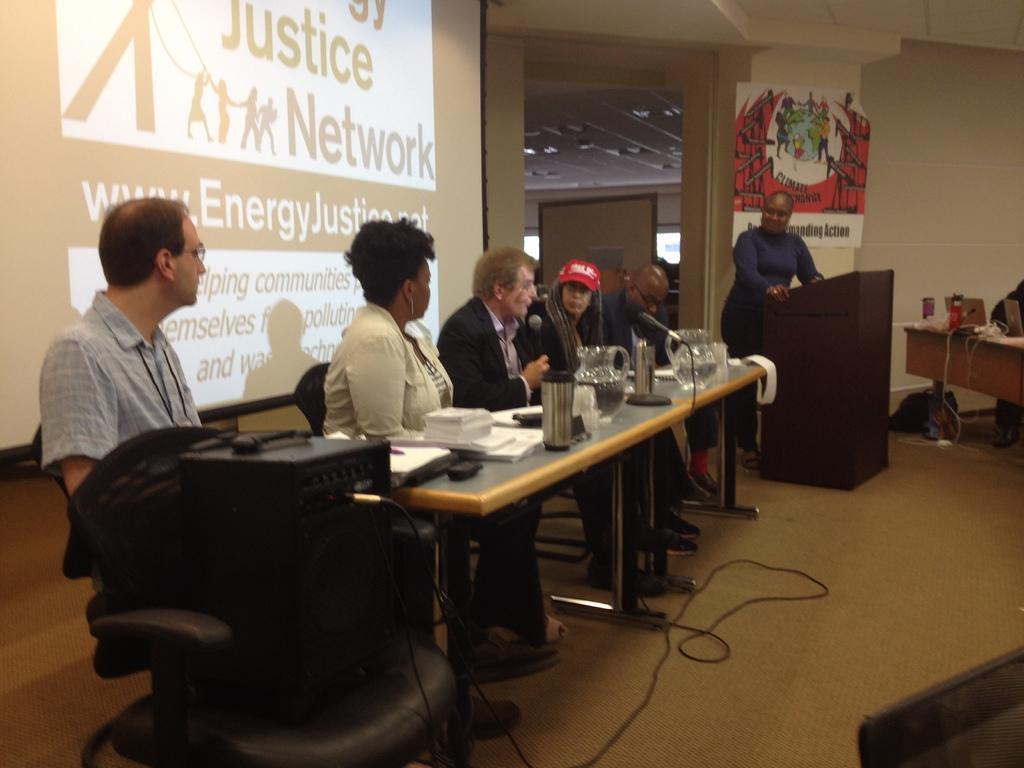Could you give a brief overview of what you see in this image? In this picture I can observe some people sitting in the chairs in front of the table on which there are some papers, glasses and a mic is placed. On the right side there is a person standing in front of a podium. Behind the person I can observe a poster hanged to the wall. On the left side there is a projector display screen. 